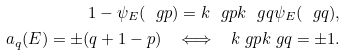<formula> <loc_0><loc_0><loc_500><loc_500>1 - \psi _ { E } ( \ g p ) = { k } { \ g p } { k } { \ g q } \psi _ { E } ( \ g q ) , \\ a _ { q } ( E ) = \pm ( q + 1 - p ) \quad \Longleftrightarrow \quad { k } { \ g p } { k } { \ g q } = \pm 1 .</formula> 